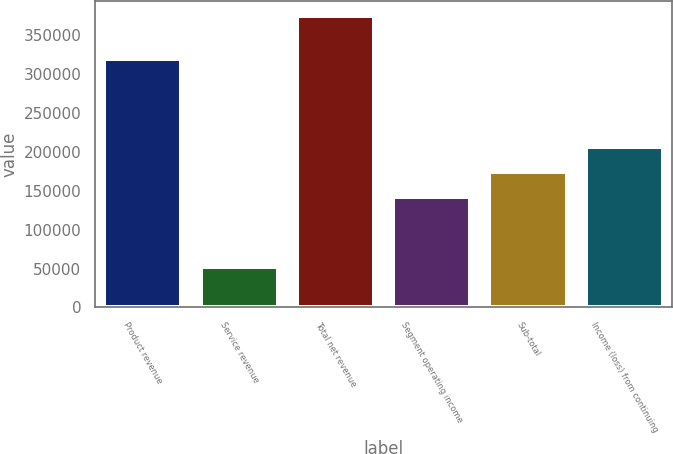Convert chart. <chart><loc_0><loc_0><loc_500><loc_500><bar_chart><fcel>Product revenue<fcel>Service revenue<fcel>Total net revenue<fcel>Segment operating income<fcel>Sub-total<fcel>Income (loss) from continuing<nl><fcel>318764<fcel>51453<fcel>374617<fcel>141346<fcel>173662<fcel>205979<nl></chart> 